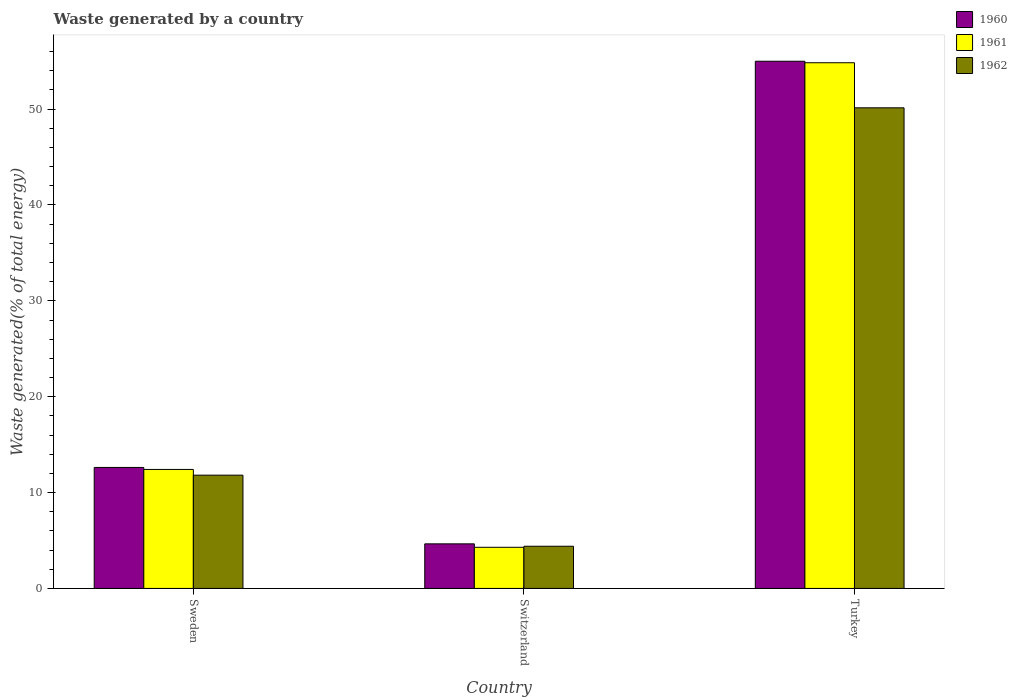Are the number of bars per tick equal to the number of legend labels?
Offer a terse response. Yes. Are the number of bars on each tick of the X-axis equal?
Make the answer very short. Yes. How many bars are there on the 3rd tick from the right?
Offer a very short reply. 3. What is the label of the 2nd group of bars from the left?
Offer a very short reply. Switzerland. In how many cases, is the number of bars for a given country not equal to the number of legend labels?
Offer a terse response. 0. What is the total waste generated in 1960 in Sweden?
Keep it short and to the point. 12.62. Across all countries, what is the maximum total waste generated in 1961?
Make the answer very short. 54.84. Across all countries, what is the minimum total waste generated in 1961?
Your response must be concise. 4.29. In which country was the total waste generated in 1961 maximum?
Your response must be concise. Turkey. In which country was the total waste generated in 1960 minimum?
Keep it short and to the point. Switzerland. What is the total total waste generated in 1961 in the graph?
Give a very brief answer. 71.54. What is the difference between the total waste generated in 1962 in Switzerland and that in Turkey?
Your answer should be compact. -45.73. What is the difference between the total waste generated in 1961 in Sweden and the total waste generated in 1962 in Turkey?
Provide a short and direct response. -37.72. What is the average total waste generated in 1962 per country?
Ensure brevity in your answer.  22.12. What is the difference between the total waste generated of/in 1962 and total waste generated of/in 1960 in Switzerland?
Your answer should be very brief. -0.25. What is the ratio of the total waste generated in 1961 in Sweden to that in Switzerland?
Provide a short and direct response. 2.89. Is the difference between the total waste generated in 1962 in Sweden and Turkey greater than the difference between the total waste generated in 1960 in Sweden and Turkey?
Your response must be concise. Yes. What is the difference between the highest and the second highest total waste generated in 1962?
Keep it short and to the point. 38.32. What is the difference between the highest and the lowest total waste generated in 1961?
Give a very brief answer. 50.55. Is the sum of the total waste generated in 1960 in Sweden and Switzerland greater than the maximum total waste generated in 1962 across all countries?
Give a very brief answer. No. What does the 1st bar from the left in Switzerland represents?
Your answer should be very brief. 1960. How many countries are there in the graph?
Give a very brief answer. 3. Does the graph contain any zero values?
Keep it short and to the point. No. Where does the legend appear in the graph?
Your answer should be compact. Top right. What is the title of the graph?
Give a very brief answer. Waste generated by a country. Does "1997" appear as one of the legend labels in the graph?
Offer a terse response. No. What is the label or title of the Y-axis?
Your answer should be compact. Waste generated(% of total energy). What is the Waste generated(% of total energy) in 1960 in Sweden?
Offer a terse response. 12.62. What is the Waste generated(% of total energy) of 1961 in Sweden?
Provide a succinct answer. 12.41. What is the Waste generated(% of total energy) of 1962 in Sweden?
Make the answer very short. 11.82. What is the Waste generated(% of total energy) in 1960 in Switzerland?
Provide a short and direct response. 4.65. What is the Waste generated(% of total energy) in 1961 in Switzerland?
Your answer should be compact. 4.29. What is the Waste generated(% of total energy) of 1962 in Switzerland?
Keep it short and to the point. 4.4. What is the Waste generated(% of total energy) of 1960 in Turkey?
Provide a short and direct response. 54.99. What is the Waste generated(% of total energy) of 1961 in Turkey?
Offer a terse response. 54.84. What is the Waste generated(% of total energy) of 1962 in Turkey?
Ensure brevity in your answer.  50.13. Across all countries, what is the maximum Waste generated(% of total energy) in 1960?
Your response must be concise. 54.99. Across all countries, what is the maximum Waste generated(% of total energy) in 1961?
Your response must be concise. 54.84. Across all countries, what is the maximum Waste generated(% of total energy) in 1962?
Ensure brevity in your answer.  50.13. Across all countries, what is the minimum Waste generated(% of total energy) of 1960?
Provide a succinct answer. 4.65. Across all countries, what is the minimum Waste generated(% of total energy) of 1961?
Keep it short and to the point. 4.29. Across all countries, what is the minimum Waste generated(% of total energy) in 1962?
Your answer should be very brief. 4.4. What is the total Waste generated(% of total energy) in 1960 in the graph?
Make the answer very short. 72.27. What is the total Waste generated(% of total energy) of 1961 in the graph?
Ensure brevity in your answer.  71.54. What is the total Waste generated(% of total energy) in 1962 in the graph?
Keep it short and to the point. 66.35. What is the difference between the Waste generated(% of total energy) in 1960 in Sweden and that in Switzerland?
Give a very brief answer. 7.97. What is the difference between the Waste generated(% of total energy) in 1961 in Sweden and that in Switzerland?
Give a very brief answer. 8.12. What is the difference between the Waste generated(% of total energy) in 1962 in Sweden and that in Switzerland?
Offer a terse response. 7.41. What is the difference between the Waste generated(% of total energy) in 1960 in Sweden and that in Turkey?
Offer a terse response. -42.37. What is the difference between the Waste generated(% of total energy) of 1961 in Sweden and that in Turkey?
Provide a succinct answer. -42.43. What is the difference between the Waste generated(% of total energy) of 1962 in Sweden and that in Turkey?
Your response must be concise. -38.32. What is the difference between the Waste generated(% of total energy) of 1960 in Switzerland and that in Turkey?
Offer a terse response. -50.34. What is the difference between the Waste generated(% of total energy) of 1961 in Switzerland and that in Turkey?
Your answer should be very brief. -50.55. What is the difference between the Waste generated(% of total energy) in 1962 in Switzerland and that in Turkey?
Keep it short and to the point. -45.73. What is the difference between the Waste generated(% of total energy) of 1960 in Sweden and the Waste generated(% of total energy) of 1961 in Switzerland?
Your answer should be compact. 8.33. What is the difference between the Waste generated(% of total energy) of 1960 in Sweden and the Waste generated(% of total energy) of 1962 in Switzerland?
Your response must be concise. 8.22. What is the difference between the Waste generated(% of total energy) of 1961 in Sweden and the Waste generated(% of total energy) of 1962 in Switzerland?
Your answer should be compact. 8.01. What is the difference between the Waste generated(% of total energy) of 1960 in Sweden and the Waste generated(% of total energy) of 1961 in Turkey?
Your response must be concise. -42.22. What is the difference between the Waste generated(% of total energy) of 1960 in Sweden and the Waste generated(% of total energy) of 1962 in Turkey?
Your answer should be very brief. -37.51. What is the difference between the Waste generated(% of total energy) in 1961 in Sweden and the Waste generated(% of total energy) in 1962 in Turkey?
Keep it short and to the point. -37.72. What is the difference between the Waste generated(% of total energy) in 1960 in Switzerland and the Waste generated(% of total energy) in 1961 in Turkey?
Ensure brevity in your answer.  -50.19. What is the difference between the Waste generated(% of total energy) of 1960 in Switzerland and the Waste generated(% of total energy) of 1962 in Turkey?
Keep it short and to the point. -45.48. What is the difference between the Waste generated(% of total energy) of 1961 in Switzerland and the Waste generated(% of total energy) of 1962 in Turkey?
Give a very brief answer. -45.84. What is the average Waste generated(% of total energy) in 1960 per country?
Ensure brevity in your answer.  24.09. What is the average Waste generated(% of total energy) in 1961 per country?
Provide a succinct answer. 23.85. What is the average Waste generated(% of total energy) in 1962 per country?
Give a very brief answer. 22.12. What is the difference between the Waste generated(% of total energy) in 1960 and Waste generated(% of total energy) in 1961 in Sweden?
Offer a very short reply. 0.21. What is the difference between the Waste generated(% of total energy) of 1960 and Waste generated(% of total energy) of 1962 in Sweden?
Keep it short and to the point. 0.81. What is the difference between the Waste generated(% of total energy) of 1961 and Waste generated(% of total energy) of 1962 in Sweden?
Ensure brevity in your answer.  0.6. What is the difference between the Waste generated(% of total energy) of 1960 and Waste generated(% of total energy) of 1961 in Switzerland?
Your response must be concise. 0.36. What is the difference between the Waste generated(% of total energy) of 1960 and Waste generated(% of total energy) of 1962 in Switzerland?
Keep it short and to the point. 0.25. What is the difference between the Waste generated(% of total energy) in 1961 and Waste generated(% of total energy) in 1962 in Switzerland?
Keep it short and to the point. -0.11. What is the difference between the Waste generated(% of total energy) in 1960 and Waste generated(% of total energy) in 1961 in Turkey?
Your answer should be very brief. 0.16. What is the difference between the Waste generated(% of total energy) of 1960 and Waste generated(% of total energy) of 1962 in Turkey?
Provide a succinct answer. 4.86. What is the difference between the Waste generated(% of total energy) of 1961 and Waste generated(% of total energy) of 1962 in Turkey?
Offer a very short reply. 4.7. What is the ratio of the Waste generated(% of total energy) of 1960 in Sweden to that in Switzerland?
Your answer should be very brief. 2.71. What is the ratio of the Waste generated(% of total energy) in 1961 in Sweden to that in Switzerland?
Your answer should be very brief. 2.89. What is the ratio of the Waste generated(% of total energy) in 1962 in Sweden to that in Switzerland?
Offer a very short reply. 2.68. What is the ratio of the Waste generated(% of total energy) of 1960 in Sweden to that in Turkey?
Offer a very short reply. 0.23. What is the ratio of the Waste generated(% of total energy) in 1961 in Sweden to that in Turkey?
Your answer should be compact. 0.23. What is the ratio of the Waste generated(% of total energy) in 1962 in Sweden to that in Turkey?
Your response must be concise. 0.24. What is the ratio of the Waste generated(% of total energy) of 1960 in Switzerland to that in Turkey?
Give a very brief answer. 0.08. What is the ratio of the Waste generated(% of total energy) in 1961 in Switzerland to that in Turkey?
Your answer should be compact. 0.08. What is the ratio of the Waste generated(% of total energy) in 1962 in Switzerland to that in Turkey?
Provide a succinct answer. 0.09. What is the difference between the highest and the second highest Waste generated(% of total energy) in 1960?
Give a very brief answer. 42.37. What is the difference between the highest and the second highest Waste generated(% of total energy) in 1961?
Provide a short and direct response. 42.43. What is the difference between the highest and the second highest Waste generated(% of total energy) in 1962?
Give a very brief answer. 38.32. What is the difference between the highest and the lowest Waste generated(% of total energy) in 1960?
Offer a terse response. 50.34. What is the difference between the highest and the lowest Waste generated(% of total energy) in 1961?
Your answer should be very brief. 50.55. What is the difference between the highest and the lowest Waste generated(% of total energy) in 1962?
Your answer should be very brief. 45.73. 